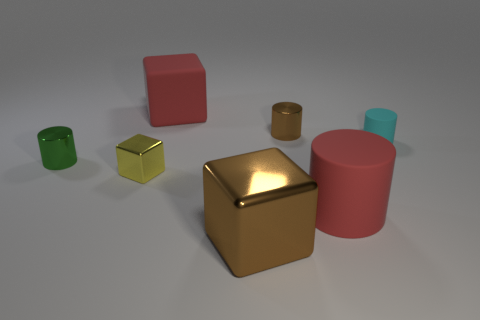Is the number of tiny shiny cylinders greater than the number of tiny metallic things?
Your response must be concise. No. What number of objects are red things to the right of the big rubber block or tiny brown metallic cylinders?
Offer a very short reply. 2. Is there a matte cube of the same size as the cyan rubber cylinder?
Offer a very short reply. No. Is the number of red matte cylinders less than the number of large objects?
Make the answer very short. Yes. What number of cylinders are yellow metal objects or brown metal things?
Give a very brief answer. 1. What number of large metal blocks are the same color as the large shiny thing?
Provide a short and direct response. 0. There is a cube that is both behind the brown shiny block and in front of the cyan cylinder; what is its size?
Ensure brevity in your answer.  Small. Are there fewer green cylinders to the right of the yellow block than tiny gray metallic blocks?
Ensure brevity in your answer.  No. Do the tiny green cylinder and the small cyan cylinder have the same material?
Your answer should be very brief. No. What number of objects are small metallic blocks or small cyan cubes?
Provide a short and direct response. 1. 